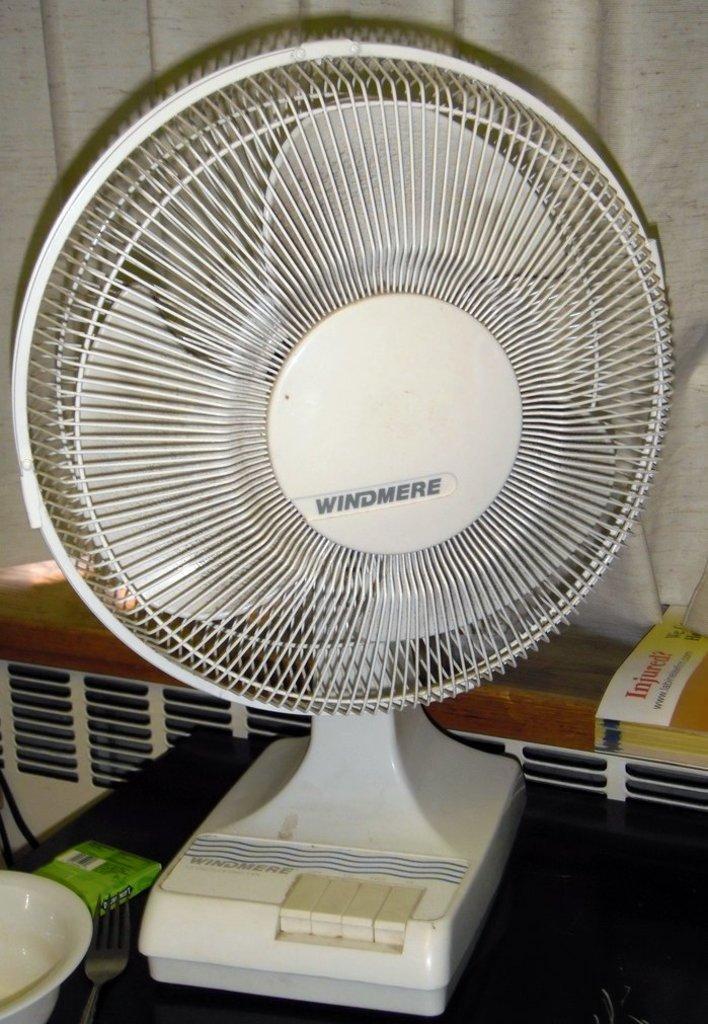How would you summarize this image in a sentence or two? In this image we can see one white table fan with text, one bowl, one fork and one green object on the black table. There is one curtain in the background, one book on the wooden surface, two black wires on the bottom left side of the image, one object looks like a cloth on the book and one object behind the black table. 